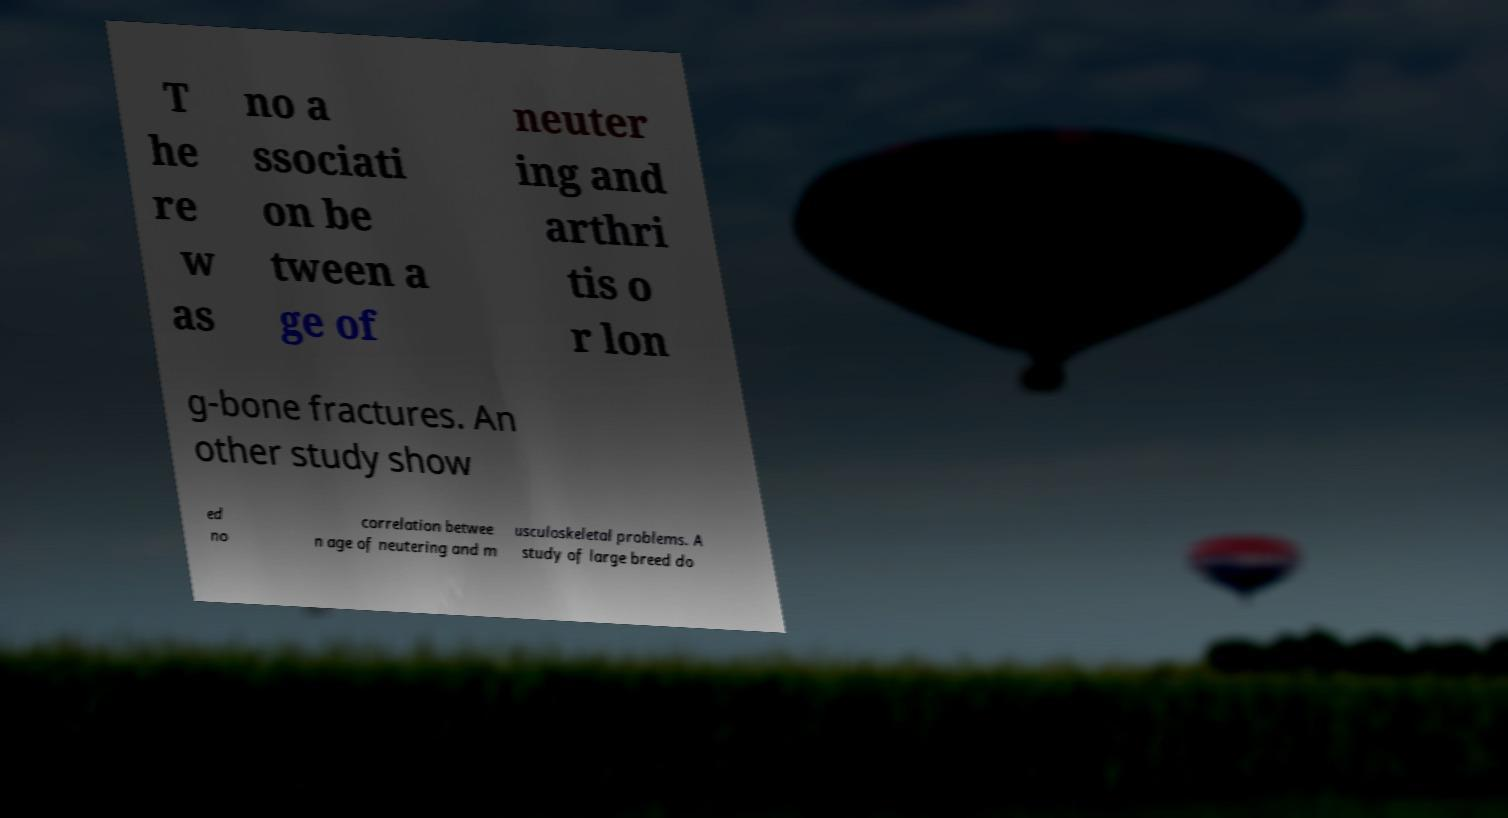Could you extract and type out the text from this image? T he re w as no a ssociati on be tween a ge of neuter ing and arthri tis o r lon g-bone fractures. An other study show ed no correlation betwee n age of neutering and m usculoskeletal problems. A study of large breed do 